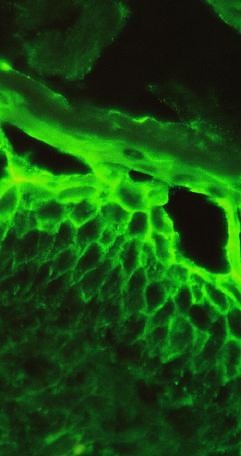re only a few areas of pale squamous mucosa confined to superficial layers of the epidermis?
Answer the question using a single word or phrase. No 